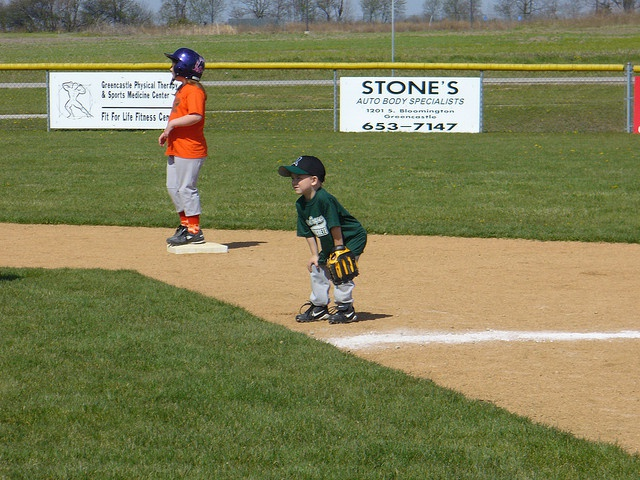Describe the objects in this image and their specific colors. I can see people in gray, black, darkgray, and teal tones, people in gray, red, darkgray, and maroon tones, and baseball glove in gray, black, orange, and olive tones in this image. 